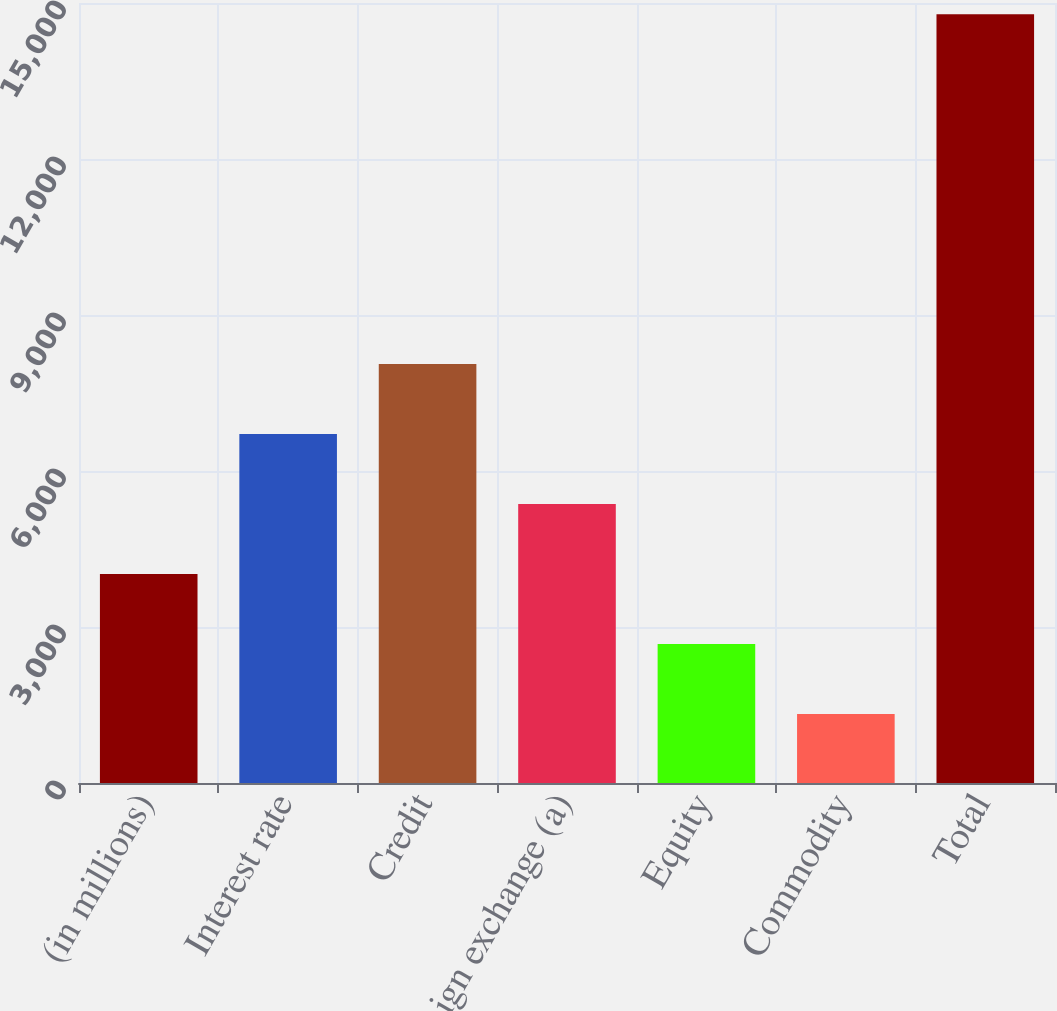<chart> <loc_0><loc_0><loc_500><loc_500><bar_chart><fcel>(in millions)<fcel>Interest rate<fcel>Credit<fcel>Foreign exchange (a)<fcel>Equity<fcel>Commodity<fcel>Total<nl><fcel>4020<fcel>6711<fcel>8056.5<fcel>5365.5<fcel>2674.5<fcel>1329<fcel>14784<nl></chart> 